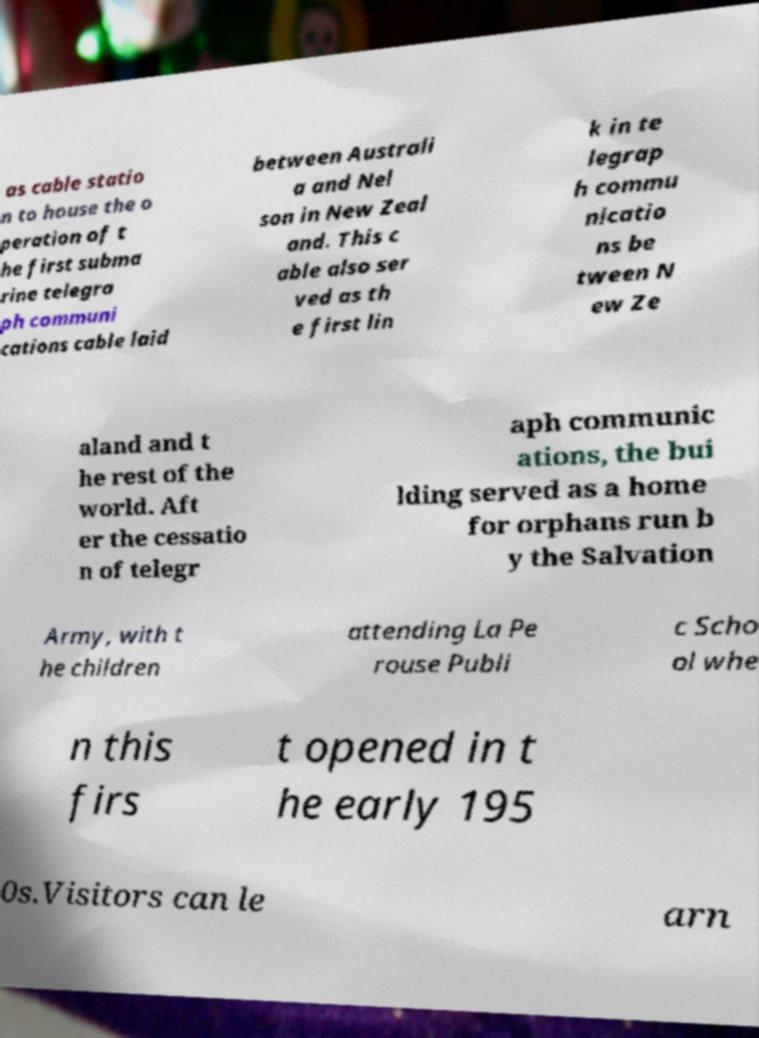Please identify and transcribe the text found in this image. as cable statio n to house the o peration of t he first subma rine telegra ph communi cations cable laid between Australi a and Nel son in New Zeal and. This c able also ser ved as th e first lin k in te legrap h commu nicatio ns be tween N ew Ze aland and t he rest of the world. Aft er the cessatio n of telegr aph communic ations, the bui lding served as a home for orphans run b y the Salvation Army, with t he children attending La Pe rouse Publi c Scho ol whe n this firs t opened in t he early 195 0s.Visitors can le arn 